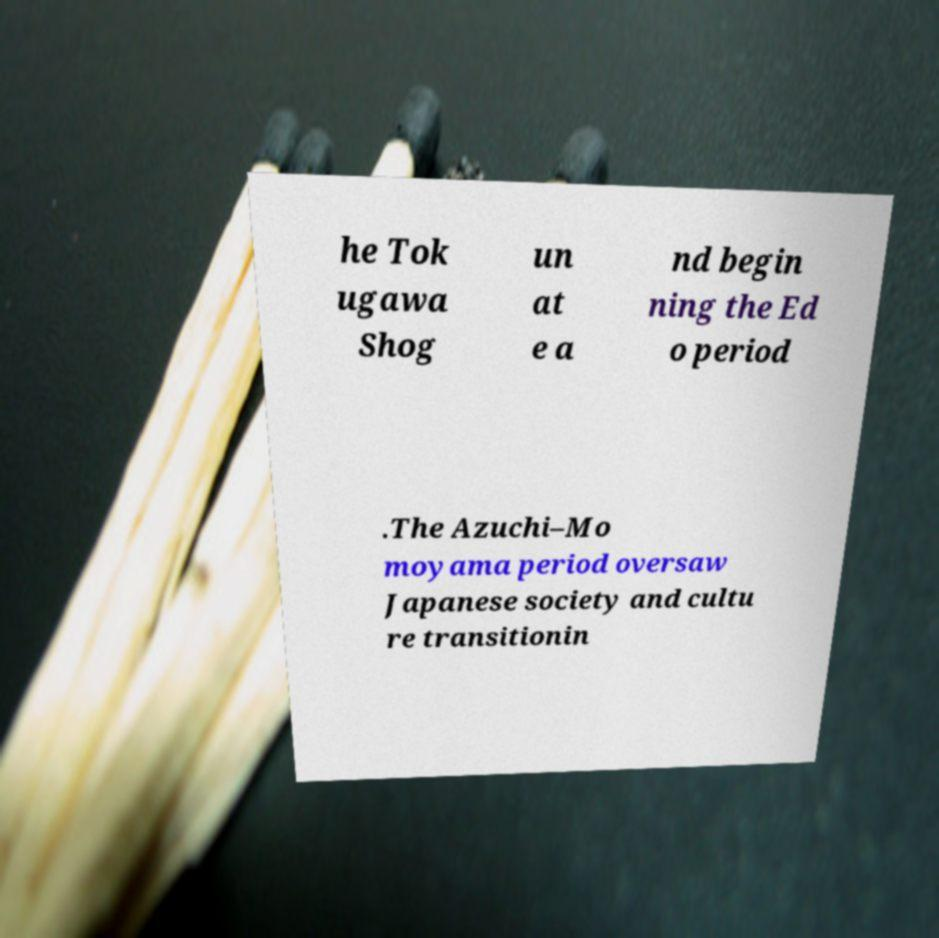For documentation purposes, I need the text within this image transcribed. Could you provide that? he Tok ugawa Shog un at e a nd begin ning the Ed o period .The Azuchi–Mo moyama period oversaw Japanese society and cultu re transitionin 